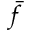Convert formula to latex. <formula><loc_0><loc_0><loc_500><loc_500>\bar { f }</formula> 